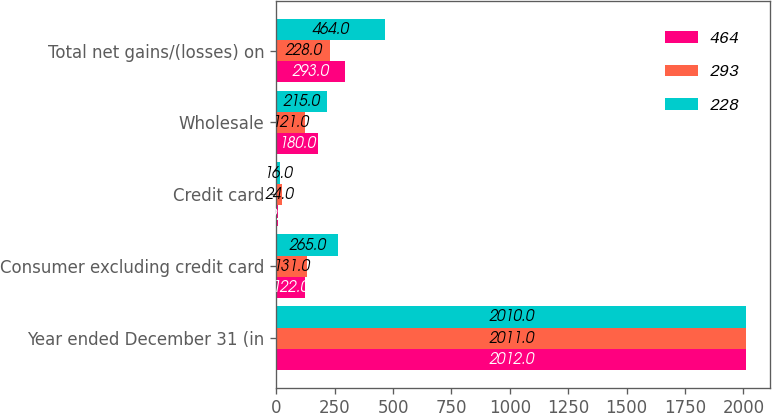<chart> <loc_0><loc_0><loc_500><loc_500><stacked_bar_chart><ecel><fcel>Year ended December 31 (in<fcel>Consumer excluding credit card<fcel>Credit card<fcel>Wholesale<fcel>Total net gains/(losses) on<nl><fcel>464<fcel>2012<fcel>122<fcel>9<fcel>180<fcel>293<nl><fcel>293<fcel>2011<fcel>131<fcel>24<fcel>121<fcel>228<nl><fcel>228<fcel>2010<fcel>265<fcel>16<fcel>215<fcel>464<nl></chart> 